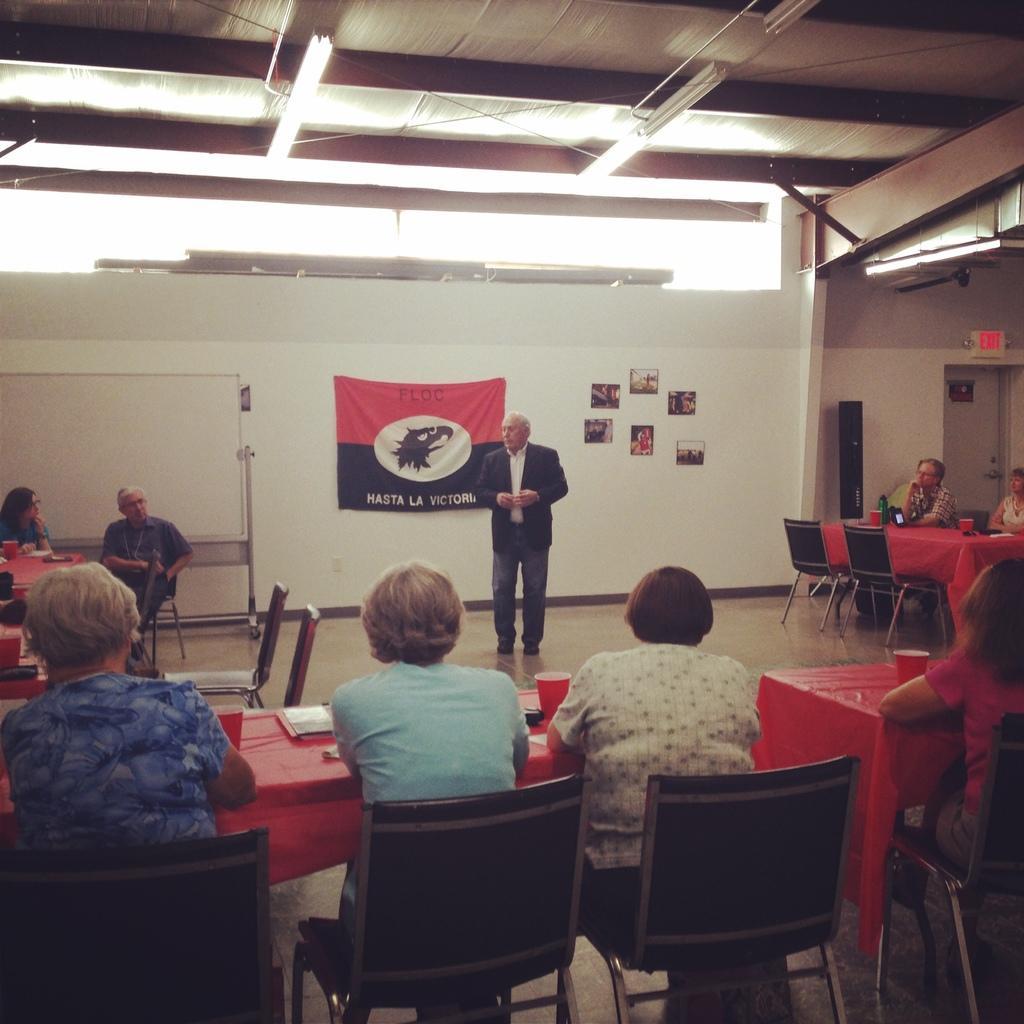How would you summarize this image in a sentence or two? These persons are sitting on a chair. On this tables there are cups. Far this person is standing and wore suit. On wall there are pictures and banner. Backside of this person there is a whiteboard with stand. On top there are lights. 